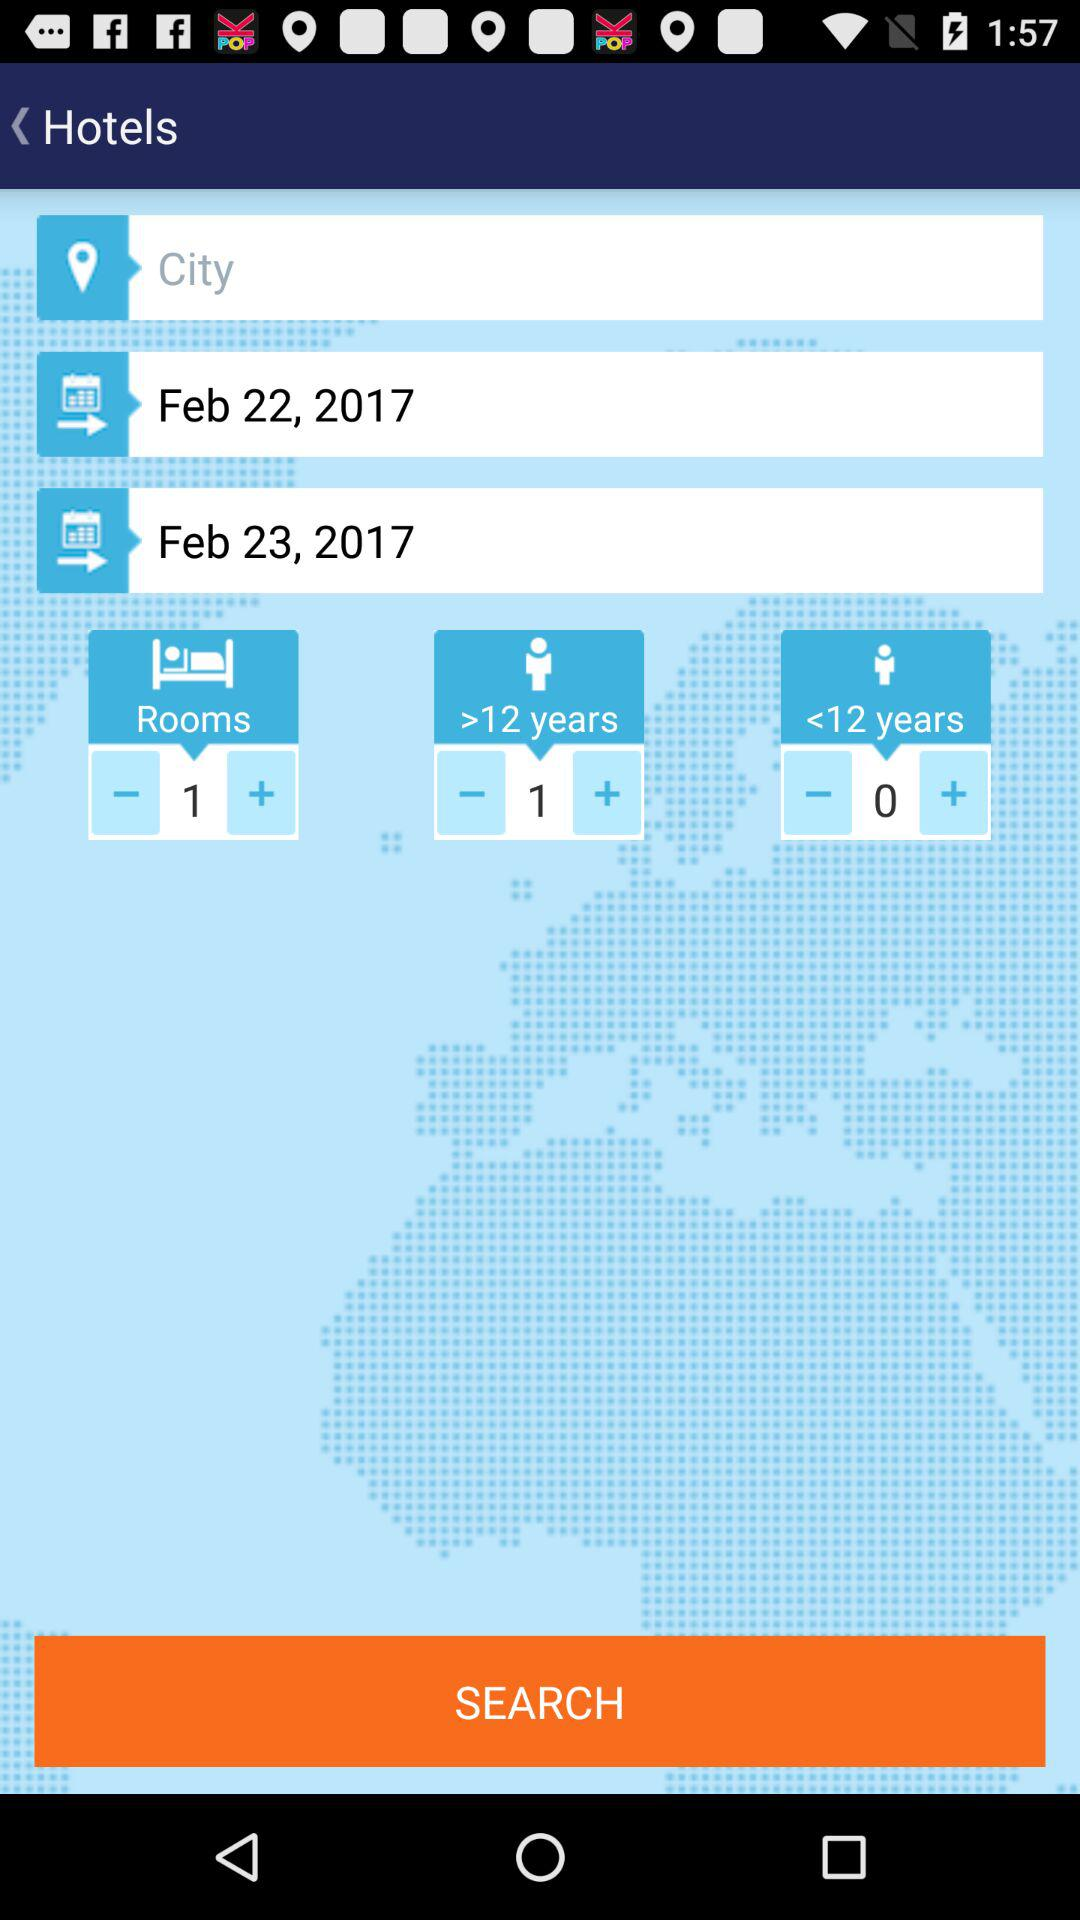What is the application name?
When the provided information is insufficient, respond with <no answer>. <no answer> 